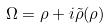Convert formula to latex. <formula><loc_0><loc_0><loc_500><loc_500>\Omega = \rho + i \tilde { \rho } ( \rho )</formula> 